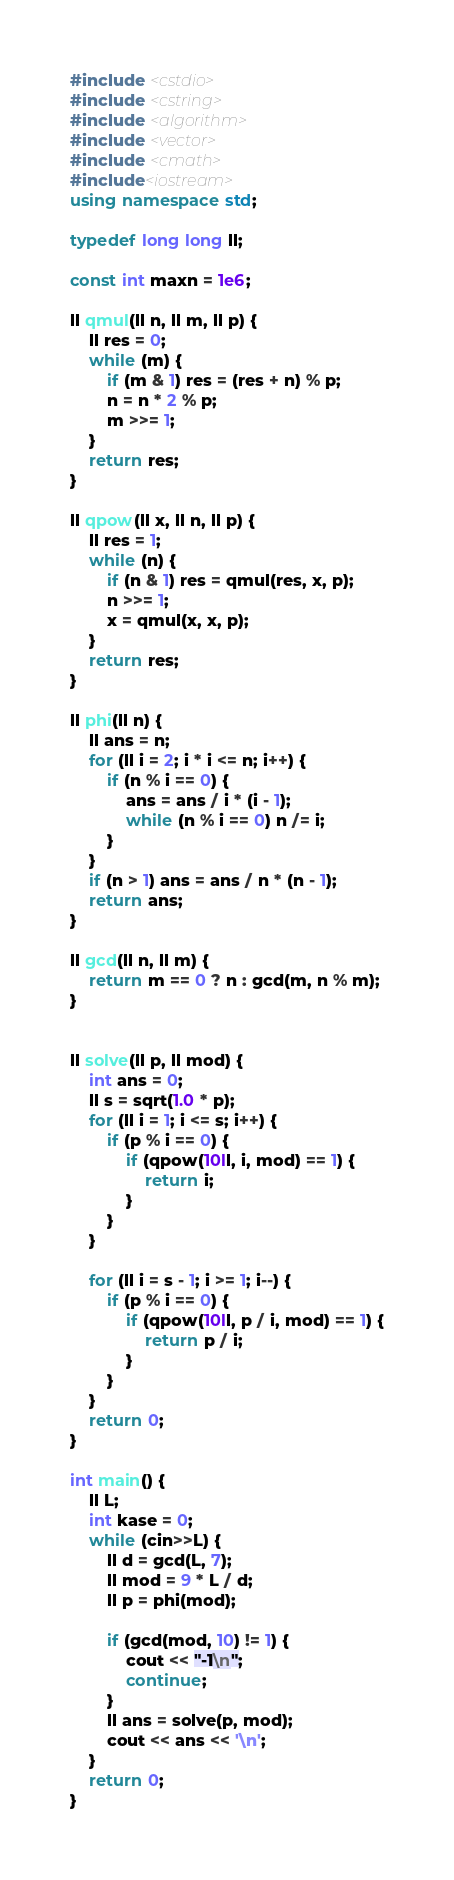<code> <loc_0><loc_0><loc_500><loc_500><_C++_>#include <cstdio>
#include <cstring>
#include <algorithm>
#include <vector>
#include <cmath>
#include<iostream>
using namespace std;

typedef long long ll;

const int maxn = 1e6;

ll qmul(ll n, ll m, ll p) {
    ll res = 0;
    while (m) {
        if (m & 1) res = (res + n) % p;
        n = n * 2 % p;
        m >>= 1;
    }
    return res;
}

ll qpow(ll x, ll n, ll p) {
    ll res = 1;
    while (n) {
        if (n & 1) res = qmul(res, x, p);
        n >>= 1;
        x = qmul(x, x, p);
    }
    return res;
}

ll phi(ll n) {
    ll ans = n;
    for (ll i = 2; i * i <= n; i++) {
        if (n % i == 0) {
            ans = ans / i * (i - 1);
            while (n % i == 0) n /= i;
        }
    }
    if (n > 1) ans = ans / n * (n - 1);
    return ans;
}

ll gcd(ll n, ll m) {
    return m == 0 ? n : gcd(m, n % m);
}


ll solve(ll p, ll mod) {
    int ans = 0;
    ll s = sqrt(1.0 * p);
    for (ll i = 1; i <= s; i++) {
        if (p % i == 0) {
            if (qpow(10ll, i, mod) == 1) {
                return i;
            }
        }
    }

    for (ll i = s - 1; i >= 1; i--) {
        if (p % i == 0) {
            if (qpow(10ll, p / i, mod) == 1) {
                return p / i;
            }
        }
    }
    return 0;
}

int main() {
    ll L;
    int kase = 0;
    while (cin>>L) {
        ll d = gcd(L, 7);
        ll mod = 9 * L / d;
        ll p = phi(mod);

        if (gcd(mod, 10) != 1) {
            cout << "-1\n";
            continue;
        }
        ll ans = solve(p, mod);
        cout << ans << '\n';
    }
    return 0;
}</code> 